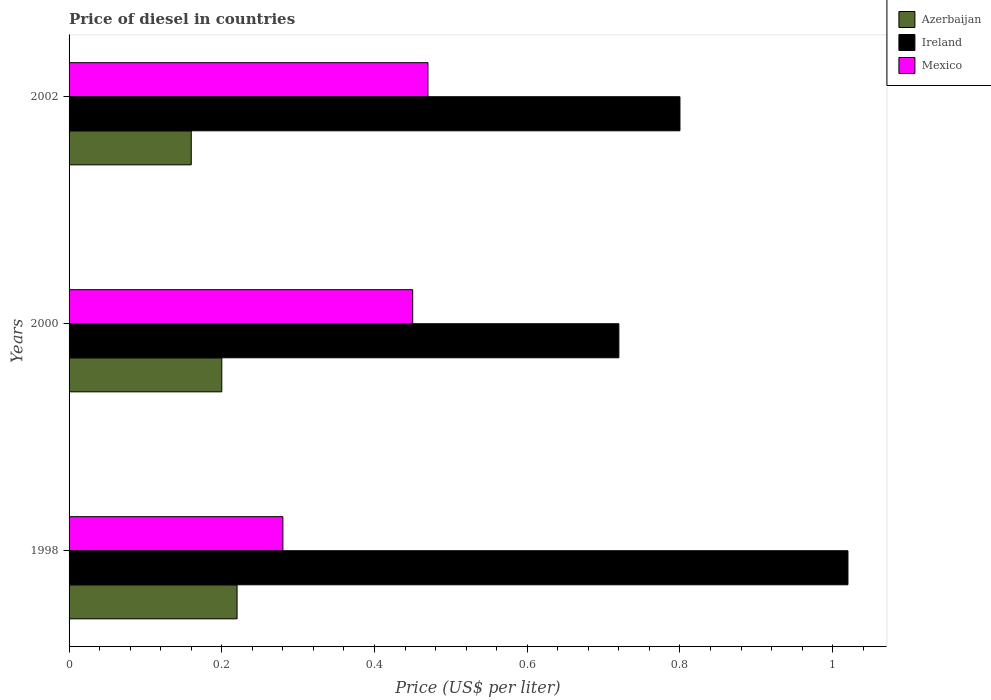How many different coloured bars are there?
Your response must be concise. 3. Are the number of bars on each tick of the Y-axis equal?
Keep it short and to the point. Yes. How many bars are there on the 2nd tick from the bottom?
Provide a succinct answer. 3. What is the label of the 3rd group of bars from the top?
Your answer should be very brief. 1998. In how many cases, is the number of bars for a given year not equal to the number of legend labels?
Your answer should be very brief. 0. What is the price of diesel in Ireland in 2000?
Your answer should be very brief. 0.72. Across all years, what is the maximum price of diesel in Mexico?
Your answer should be very brief. 0.47. Across all years, what is the minimum price of diesel in Ireland?
Provide a short and direct response. 0.72. In which year was the price of diesel in Mexico maximum?
Your answer should be compact. 2002. What is the total price of diesel in Azerbaijan in the graph?
Give a very brief answer. 0.58. What is the difference between the price of diesel in Ireland in 1998 and that in 2002?
Your answer should be very brief. 0.22. What is the difference between the price of diesel in Azerbaijan in 2000 and the price of diesel in Ireland in 2002?
Provide a short and direct response. -0.6. What is the average price of diesel in Mexico per year?
Keep it short and to the point. 0.4. In the year 1998, what is the difference between the price of diesel in Ireland and price of diesel in Mexico?
Provide a succinct answer. 0.74. What is the ratio of the price of diesel in Azerbaijan in 1998 to that in 2002?
Give a very brief answer. 1.38. Is the difference between the price of diesel in Ireland in 1998 and 2000 greater than the difference between the price of diesel in Mexico in 1998 and 2000?
Provide a short and direct response. Yes. What is the difference between the highest and the second highest price of diesel in Ireland?
Give a very brief answer. 0.22. What is the difference between the highest and the lowest price of diesel in Azerbaijan?
Your answer should be very brief. 0.06. In how many years, is the price of diesel in Azerbaijan greater than the average price of diesel in Azerbaijan taken over all years?
Your answer should be very brief. 2. Is the sum of the price of diesel in Azerbaijan in 1998 and 2002 greater than the maximum price of diesel in Ireland across all years?
Offer a very short reply. No. What does the 1st bar from the bottom in 2002 represents?
Make the answer very short. Azerbaijan. Is it the case that in every year, the sum of the price of diesel in Azerbaijan and price of diesel in Ireland is greater than the price of diesel in Mexico?
Make the answer very short. Yes. Are all the bars in the graph horizontal?
Ensure brevity in your answer.  Yes. What is the difference between two consecutive major ticks on the X-axis?
Provide a succinct answer. 0.2. Are the values on the major ticks of X-axis written in scientific E-notation?
Your answer should be compact. No. How many legend labels are there?
Provide a succinct answer. 3. How are the legend labels stacked?
Keep it short and to the point. Vertical. What is the title of the graph?
Offer a very short reply. Price of diesel in countries. What is the label or title of the X-axis?
Give a very brief answer. Price (US$ per liter). What is the Price (US$ per liter) in Azerbaijan in 1998?
Make the answer very short. 0.22. What is the Price (US$ per liter) in Mexico in 1998?
Offer a terse response. 0.28. What is the Price (US$ per liter) in Azerbaijan in 2000?
Keep it short and to the point. 0.2. What is the Price (US$ per liter) in Ireland in 2000?
Ensure brevity in your answer.  0.72. What is the Price (US$ per liter) of Mexico in 2000?
Your answer should be compact. 0.45. What is the Price (US$ per liter) of Azerbaijan in 2002?
Offer a very short reply. 0.16. What is the Price (US$ per liter) in Mexico in 2002?
Your response must be concise. 0.47. Across all years, what is the maximum Price (US$ per liter) of Azerbaijan?
Keep it short and to the point. 0.22. Across all years, what is the maximum Price (US$ per liter) in Ireland?
Keep it short and to the point. 1.02. Across all years, what is the maximum Price (US$ per liter) in Mexico?
Offer a very short reply. 0.47. Across all years, what is the minimum Price (US$ per liter) of Azerbaijan?
Offer a terse response. 0.16. Across all years, what is the minimum Price (US$ per liter) in Ireland?
Keep it short and to the point. 0.72. Across all years, what is the minimum Price (US$ per liter) in Mexico?
Provide a short and direct response. 0.28. What is the total Price (US$ per liter) in Azerbaijan in the graph?
Offer a terse response. 0.58. What is the total Price (US$ per liter) of Ireland in the graph?
Your response must be concise. 2.54. What is the difference between the Price (US$ per liter) of Azerbaijan in 1998 and that in 2000?
Your answer should be very brief. 0.02. What is the difference between the Price (US$ per liter) in Ireland in 1998 and that in 2000?
Your answer should be very brief. 0.3. What is the difference between the Price (US$ per liter) of Mexico in 1998 and that in 2000?
Provide a succinct answer. -0.17. What is the difference between the Price (US$ per liter) in Ireland in 1998 and that in 2002?
Offer a terse response. 0.22. What is the difference between the Price (US$ per liter) in Mexico in 1998 and that in 2002?
Provide a succinct answer. -0.19. What is the difference between the Price (US$ per liter) in Azerbaijan in 2000 and that in 2002?
Provide a succinct answer. 0.04. What is the difference between the Price (US$ per liter) of Ireland in 2000 and that in 2002?
Ensure brevity in your answer.  -0.08. What is the difference between the Price (US$ per liter) of Mexico in 2000 and that in 2002?
Your response must be concise. -0.02. What is the difference between the Price (US$ per liter) of Azerbaijan in 1998 and the Price (US$ per liter) of Ireland in 2000?
Offer a terse response. -0.5. What is the difference between the Price (US$ per liter) of Azerbaijan in 1998 and the Price (US$ per liter) of Mexico in 2000?
Make the answer very short. -0.23. What is the difference between the Price (US$ per liter) of Ireland in 1998 and the Price (US$ per liter) of Mexico in 2000?
Offer a terse response. 0.57. What is the difference between the Price (US$ per liter) of Azerbaijan in 1998 and the Price (US$ per liter) of Ireland in 2002?
Your answer should be compact. -0.58. What is the difference between the Price (US$ per liter) in Azerbaijan in 1998 and the Price (US$ per liter) in Mexico in 2002?
Offer a very short reply. -0.25. What is the difference between the Price (US$ per liter) in Ireland in 1998 and the Price (US$ per liter) in Mexico in 2002?
Provide a succinct answer. 0.55. What is the difference between the Price (US$ per liter) of Azerbaijan in 2000 and the Price (US$ per liter) of Ireland in 2002?
Give a very brief answer. -0.6. What is the difference between the Price (US$ per liter) of Azerbaijan in 2000 and the Price (US$ per liter) of Mexico in 2002?
Provide a succinct answer. -0.27. What is the difference between the Price (US$ per liter) in Ireland in 2000 and the Price (US$ per liter) in Mexico in 2002?
Ensure brevity in your answer.  0.25. What is the average Price (US$ per liter) in Azerbaijan per year?
Offer a very short reply. 0.19. What is the average Price (US$ per liter) in Ireland per year?
Offer a very short reply. 0.85. In the year 1998, what is the difference between the Price (US$ per liter) of Azerbaijan and Price (US$ per liter) of Ireland?
Your answer should be very brief. -0.8. In the year 1998, what is the difference between the Price (US$ per liter) of Azerbaijan and Price (US$ per liter) of Mexico?
Your response must be concise. -0.06. In the year 1998, what is the difference between the Price (US$ per liter) in Ireland and Price (US$ per liter) in Mexico?
Keep it short and to the point. 0.74. In the year 2000, what is the difference between the Price (US$ per liter) of Azerbaijan and Price (US$ per liter) of Ireland?
Keep it short and to the point. -0.52. In the year 2000, what is the difference between the Price (US$ per liter) of Ireland and Price (US$ per liter) of Mexico?
Make the answer very short. 0.27. In the year 2002, what is the difference between the Price (US$ per liter) in Azerbaijan and Price (US$ per liter) in Ireland?
Your answer should be very brief. -0.64. In the year 2002, what is the difference between the Price (US$ per liter) of Azerbaijan and Price (US$ per liter) of Mexico?
Offer a very short reply. -0.31. In the year 2002, what is the difference between the Price (US$ per liter) of Ireland and Price (US$ per liter) of Mexico?
Give a very brief answer. 0.33. What is the ratio of the Price (US$ per liter) of Ireland in 1998 to that in 2000?
Provide a short and direct response. 1.42. What is the ratio of the Price (US$ per liter) of Mexico in 1998 to that in 2000?
Offer a very short reply. 0.62. What is the ratio of the Price (US$ per liter) of Azerbaijan in 1998 to that in 2002?
Give a very brief answer. 1.38. What is the ratio of the Price (US$ per liter) in Ireland in 1998 to that in 2002?
Make the answer very short. 1.27. What is the ratio of the Price (US$ per liter) of Mexico in 1998 to that in 2002?
Your answer should be compact. 0.6. What is the ratio of the Price (US$ per liter) in Azerbaijan in 2000 to that in 2002?
Keep it short and to the point. 1.25. What is the ratio of the Price (US$ per liter) of Ireland in 2000 to that in 2002?
Your response must be concise. 0.9. What is the ratio of the Price (US$ per liter) of Mexico in 2000 to that in 2002?
Keep it short and to the point. 0.96. What is the difference between the highest and the second highest Price (US$ per liter) in Azerbaijan?
Keep it short and to the point. 0.02. What is the difference between the highest and the second highest Price (US$ per liter) in Ireland?
Your response must be concise. 0.22. What is the difference between the highest and the lowest Price (US$ per liter) of Ireland?
Offer a very short reply. 0.3. What is the difference between the highest and the lowest Price (US$ per liter) of Mexico?
Provide a short and direct response. 0.19. 